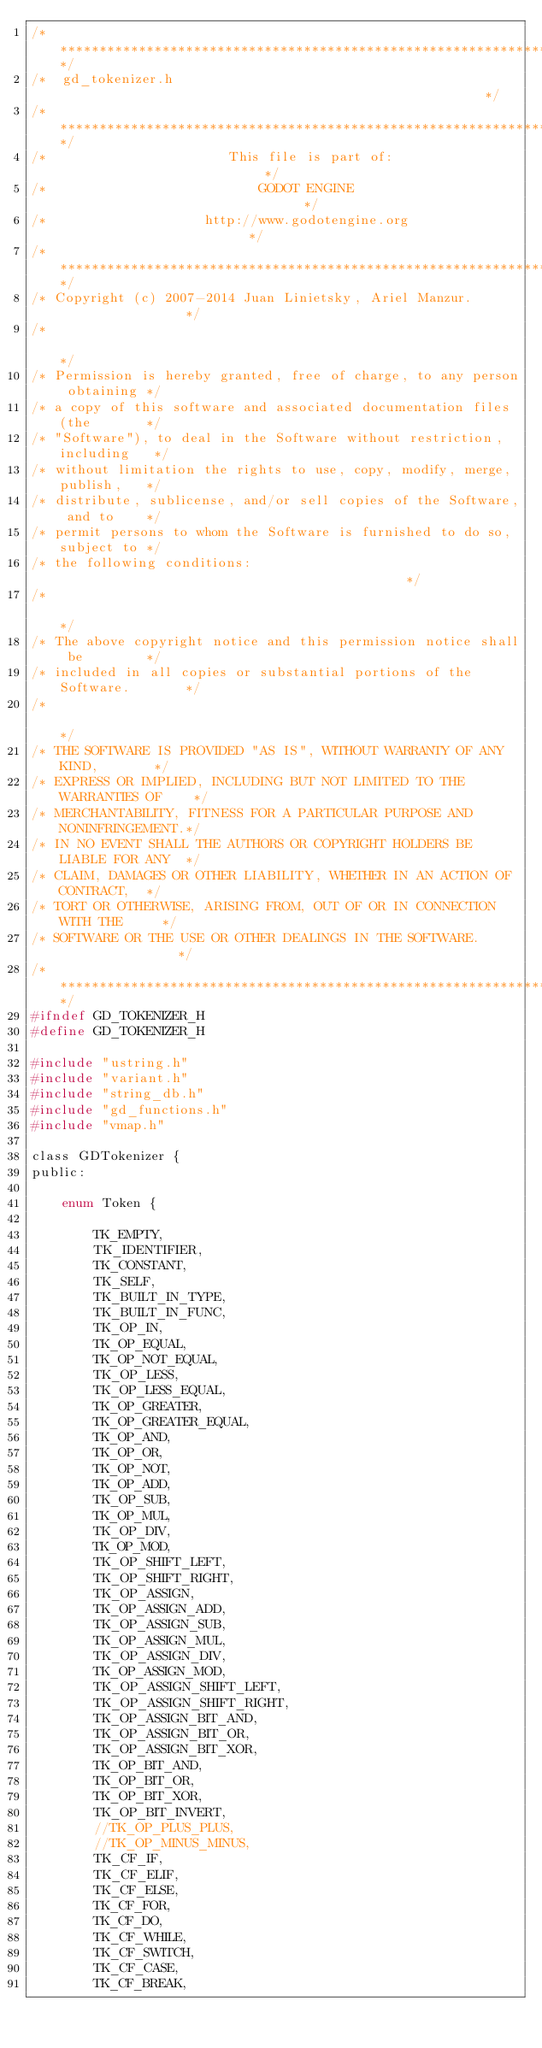Convert code to text. <code><loc_0><loc_0><loc_500><loc_500><_C_>/*************************************************************************/
/*  gd_tokenizer.h                                                       */
/*************************************************************************/
/*                       This file is part of:                           */
/*                           GODOT ENGINE                                */
/*                    http://www.godotengine.org                         */
/*************************************************************************/
/* Copyright (c) 2007-2014 Juan Linietsky, Ariel Manzur.                 */
/*                                                                       */
/* Permission is hereby granted, free of charge, to any person obtaining */
/* a copy of this software and associated documentation files (the       */
/* "Software"), to deal in the Software without restriction, including   */
/* without limitation the rights to use, copy, modify, merge, publish,   */
/* distribute, sublicense, and/or sell copies of the Software, and to    */
/* permit persons to whom the Software is furnished to do so, subject to */
/* the following conditions:                                             */
/*                                                                       */
/* The above copyright notice and this permission notice shall be        */
/* included in all copies or substantial portions of the Software.       */
/*                                                                       */
/* THE SOFTWARE IS PROVIDED "AS IS", WITHOUT WARRANTY OF ANY KIND,       */
/* EXPRESS OR IMPLIED, INCLUDING BUT NOT LIMITED TO THE WARRANTIES OF    */
/* MERCHANTABILITY, FITNESS FOR A PARTICULAR PURPOSE AND NONINFRINGEMENT.*/
/* IN NO EVENT SHALL THE AUTHORS OR COPYRIGHT HOLDERS BE LIABLE FOR ANY  */
/* CLAIM, DAMAGES OR OTHER LIABILITY, WHETHER IN AN ACTION OF CONTRACT,  */
/* TORT OR OTHERWISE, ARISING FROM, OUT OF OR IN CONNECTION WITH THE     */
/* SOFTWARE OR THE USE OR OTHER DEALINGS IN THE SOFTWARE.                */
/*************************************************************************/
#ifndef GD_TOKENIZER_H
#define GD_TOKENIZER_H

#include "ustring.h"
#include "variant.h"
#include "string_db.h"
#include "gd_functions.h"
#include "vmap.h"

class GDTokenizer {
public:

	enum Token {

		TK_EMPTY,
		TK_IDENTIFIER,
		TK_CONSTANT,
		TK_SELF,
		TK_BUILT_IN_TYPE,
		TK_BUILT_IN_FUNC,
		TK_OP_IN,
		TK_OP_EQUAL,
		TK_OP_NOT_EQUAL,
		TK_OP_LESS,
		TK_OP_LESS_EQUAL,
		TK_OP_GREATER,
		TK_OP_GREATER_EQUAL,
		TK_OP_AND,
		TK_OP_OR,
		TK_OP_NOT,
		TK_OP_ADD,
		TK_OP_SUB,
		TK_OP_MUL,
		TK_OP_DIV,
		TK_OP_MOD,
		TK_OP_SHIFT_LEFT,
		TK_OP_SHIFT_RIGHT,
		TK_OP_ASSIGN,
		TK_OP_ASSIGN_ADD,
		TK_OP_ASSIGN_SUB,
		TK_OP_ASSIGN_MUL,
		TK_OP_ASSIGN_DIV,
		TK_OP_ASSIGN_MOD,
		TK_OP_ASSIGN_SHIFT_LEFT,
		TK_OP_ASSIGN_SHIFT_RIGHT,
		TK_OP_ASSIGN_BIT_AND,
		TK_OP_ASSIGN_BIT_OR,
		TK_OP_ASSIGN_BIT_XOR,
		TK_OP_BIT_AND,
		TK_OP_BIT_OR,
		TK_OP_BIT_XOR,
		TK_OP_BIT_INVERT,
		//TK_OP_PLUS_PLUS,
		//TK_OP_MINUS_MINUS,
		TK_CF_IF,
		TK_CF_ELIF,
		TK_CF_ELSE,
		TK_CF_FOR,
		TK_CF_DO,
		TK_CF_WHILE,
		TK_CF_SWITCH,
		TK_CF_CASE,
		TK_CF_BREAK,</code> 